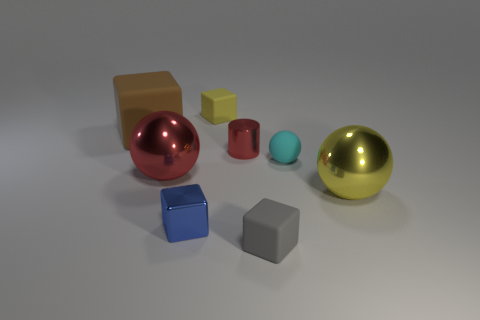There is a large shiny thing that is left of the matte object behind the brown thing; what shape is it?
Your answer should be compact. Sphere. The red shiny object that is the same size as the brown block is what shape?
Offer a terse response. Sphere. Is there a gray thing that has the same shape as the large brown thing?
Make the answer very short. Yes. What material is the brown cube?
Provide a short and direct response. Rubber. Are there any tiny matte cubes in front of the large red metal thing?
Keep it short and to the point. Yes. There is a tiny rubber cube in front of the tiny blue metallic object; what number of blue blocks are right of it?
Offer a terse response. 0. There is a red thing that is the same size as the brown rubber block; what material is it?
Offer a terse response. Metal. What number of other things are the same material as the yellow block?
Offer a terse response. 3. What number of cylinders are in front of the tiny yellow matte thing?
Offer a terse response. 1. What number of cubes are big objects or large shiny things?
Keep it short and to the point. 1. 